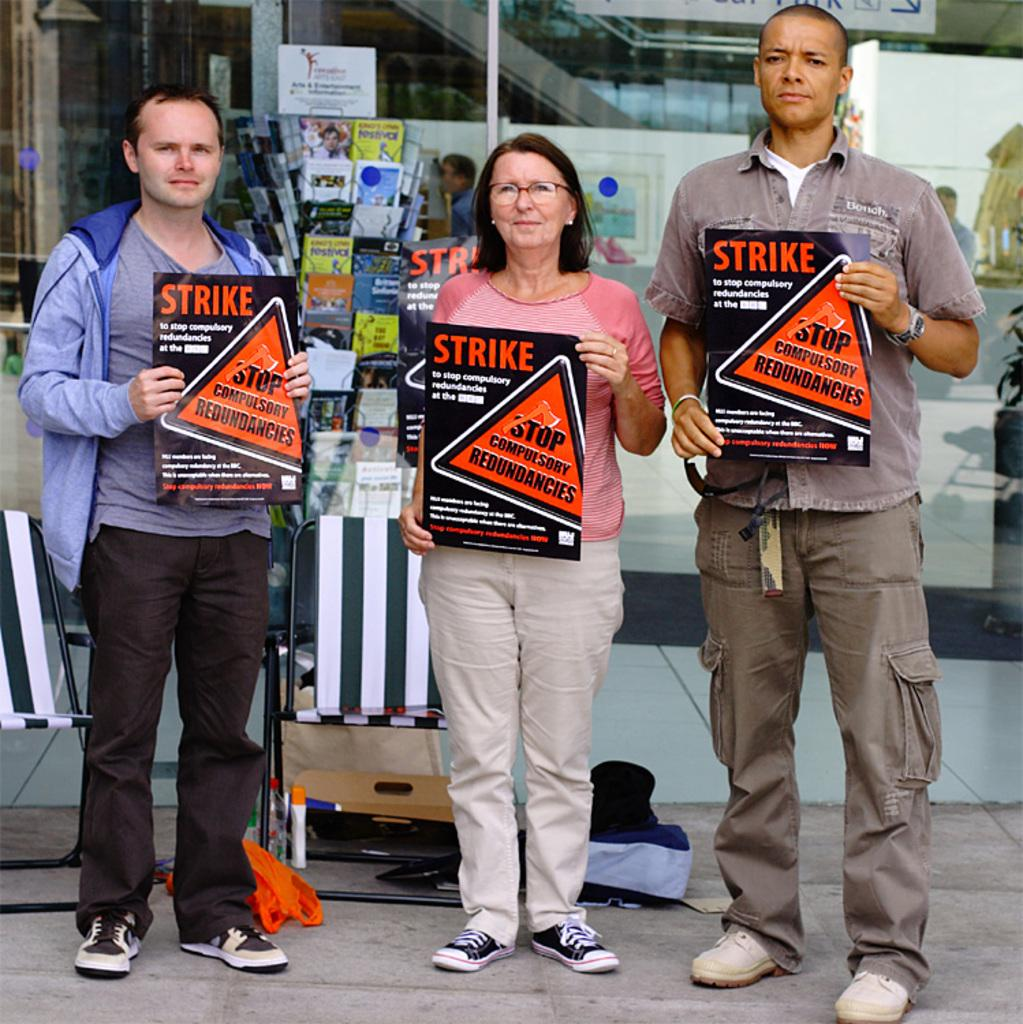What are the people in the image doing? The people in the image are standing on the road. What are the people holding in their hands? The people are holding papers. What can be seen in the background of the image? There are chairs visible in the background. What is the end of the road used for in the image? There is no indication of the end of the road in the image, so it cannot be determined what it might be used for. 